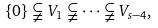Convert formula to latex. <formula><loc_0><loc_0><loc_500><loc_500>\{ 0 \} \subsetneqq V _ { 1 } \subsetneqq \dots \subsetneqq V _ { s - 4 } ,</formula> 